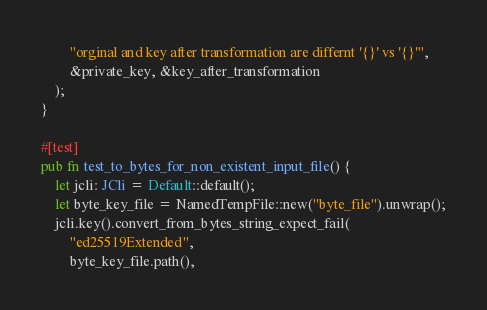<code> <loc_0><loc_0><loc_500><loc_500><_Rust_>        "orginal and key after transformation are differnt '{}' vs '{}'",
        &private_key, &key_after_transformation
    );
}

#[test]
pub fn test_to_bytes_for_non_existent_input_file() {
    let jcli: JCli = Default::default();
    let byte_key_file = NamedTempFile::new("byte_file").unwrap();
    jcli.key().convert_from_bytes_string_expect_fail(
        "ed25519Extended",
        byte_key_file.path(),</code> 